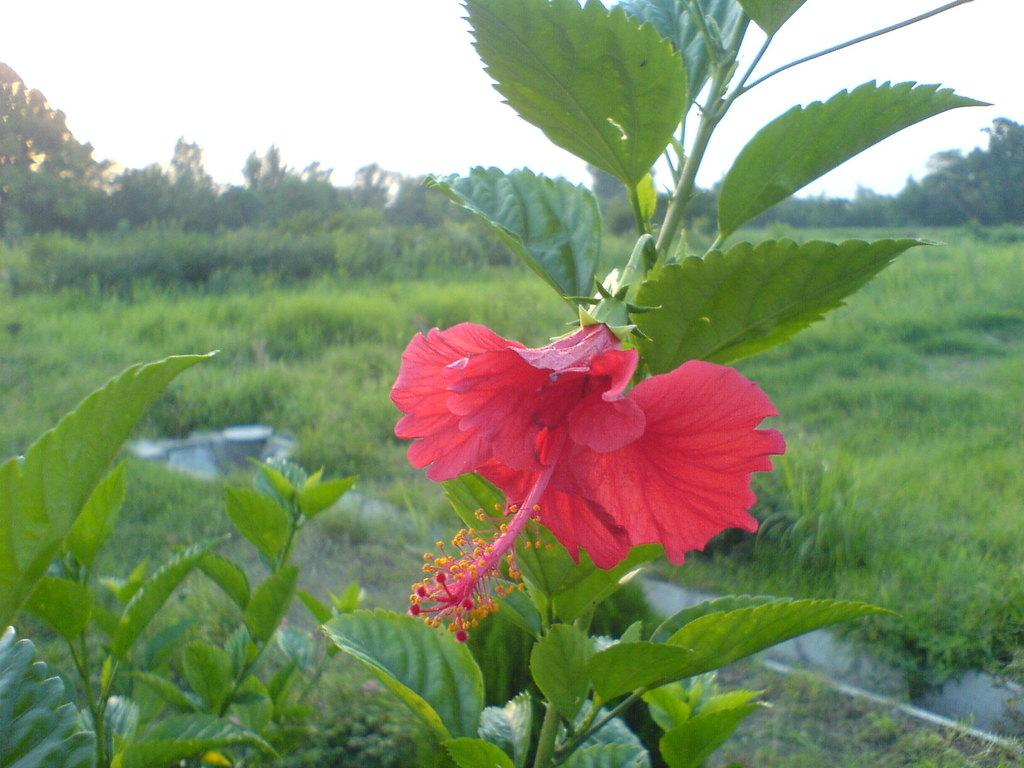What type of vegetation can be seen in the image? There are trees in the image. Can you identify any specific flowers in the image? Yes, there is a hibiscus flower in the image. What type of linen is draped over the hand in the image? There is no hand or linen present in the image; it only features trees and a hibiscus flower. How many horses are pulling the carriage in the image? There is no carriage or horses present in the image. 